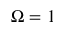Convert formula to latex. <formula><loc_0><loc_0><loc_500><loc_500>\Omega = 1</formula> 